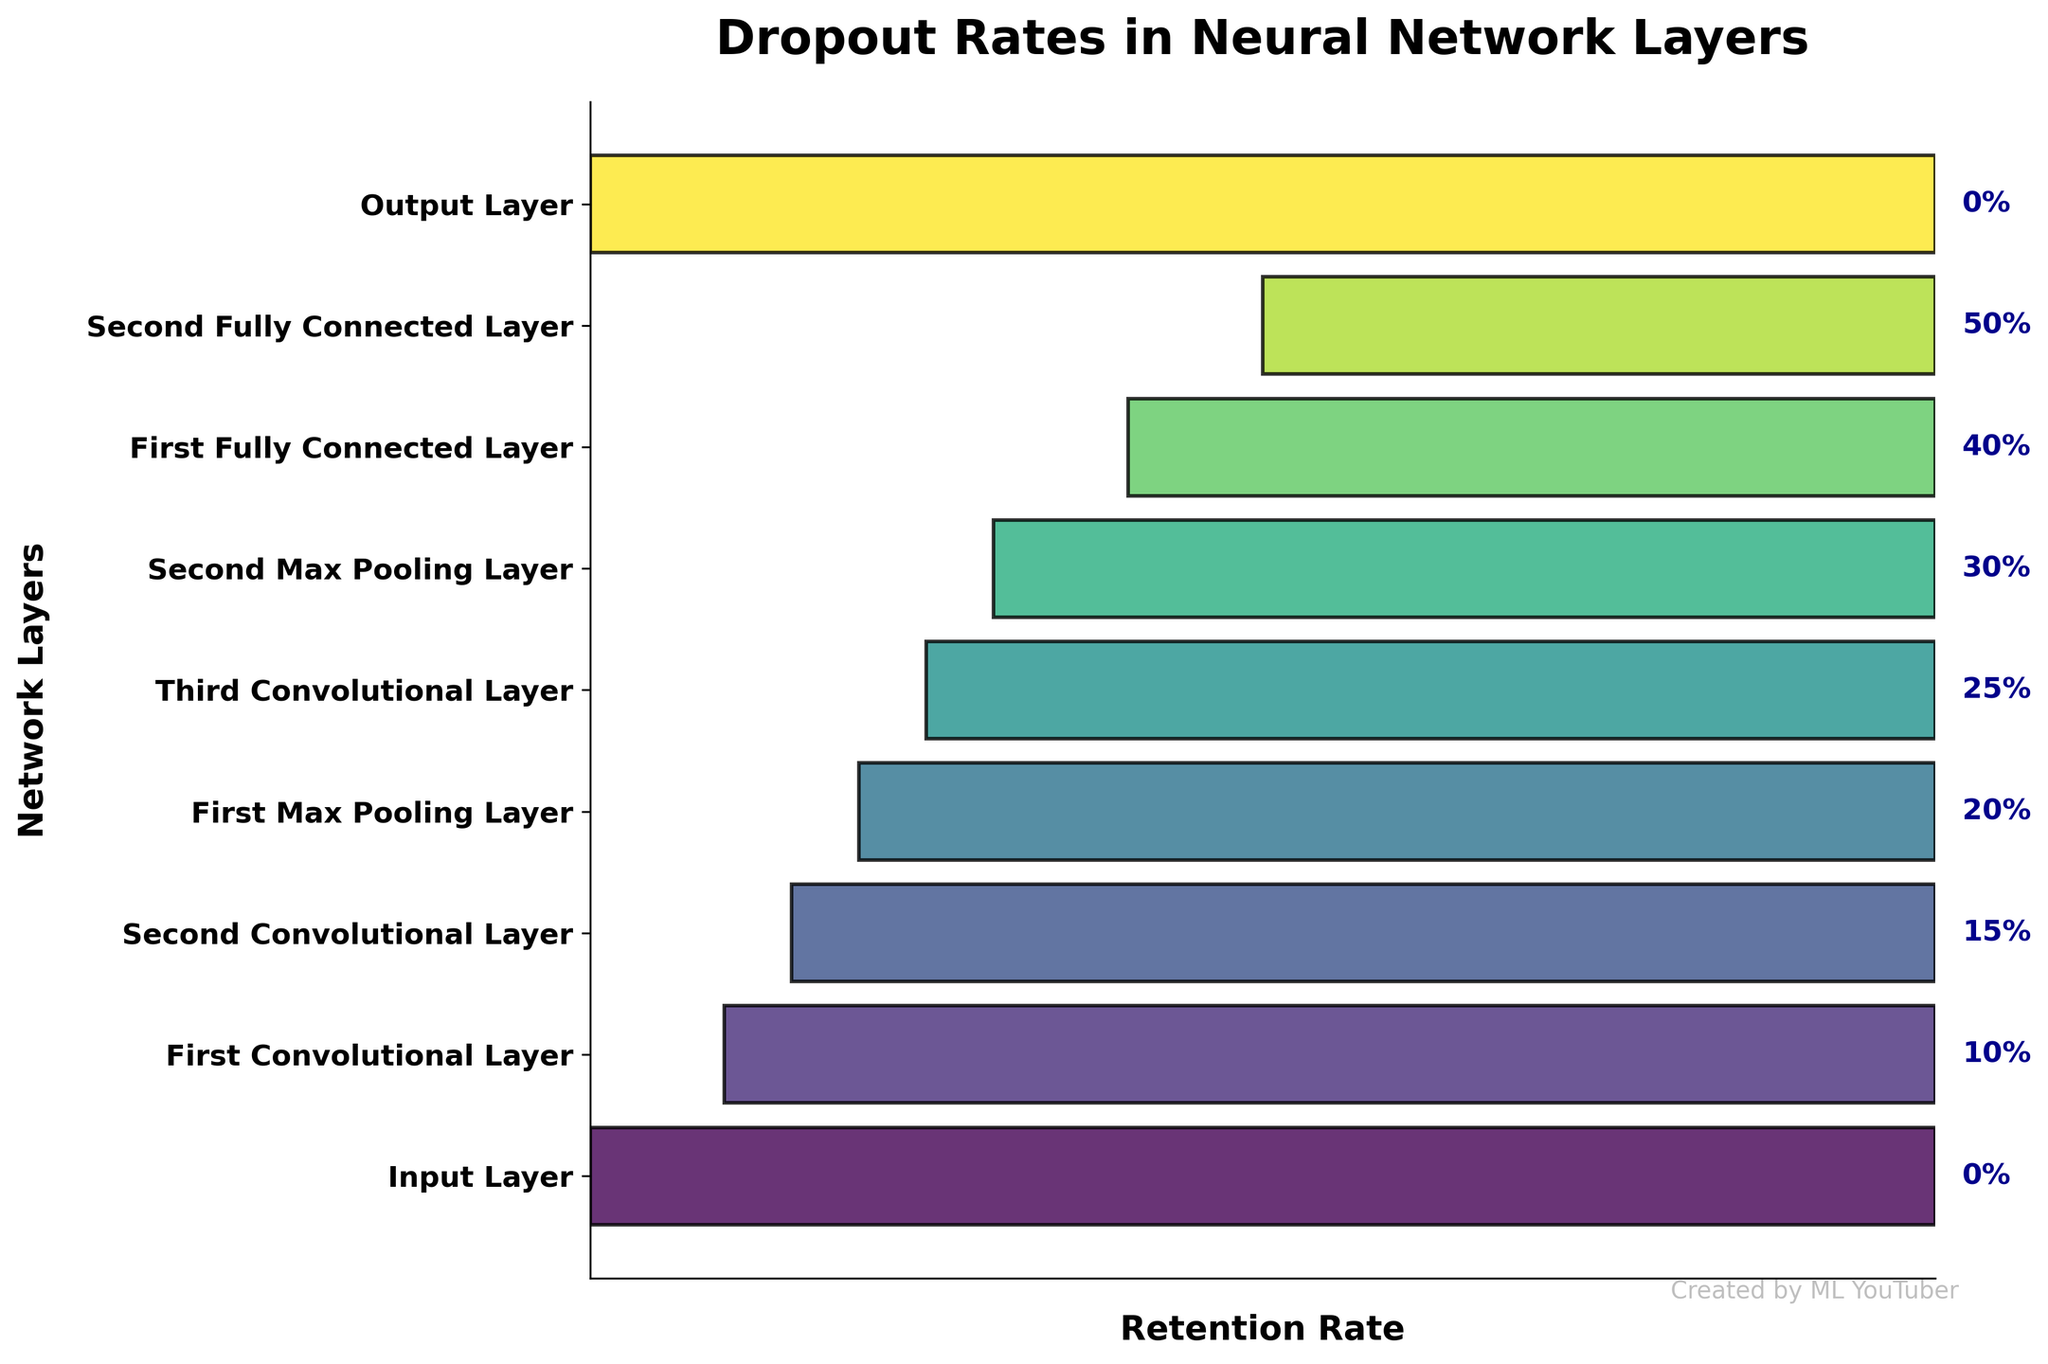How many layers have a dropout rate greater than 20%? Look at the color bars that extend beyond 20% on the percentage scale. The relevant stages are 'Third Convolutional Layer', 'Second Max Pooling Layer', 'First Fully Connected Layer', and 'Second Fully Connected Layer', making a total of 4.
Answer: 4 What is the dropout rate of the 'First Max Pooling Layer'? Find the 'First Max Pooling Layer' on the vertical axis and check the percentage label aligned with it. The dropout rate is shown as 20%.
Answer: 20% Which layer has the highest dropout rate? Identify the layer with the largest shaded segment. The 'Second Fully Connected Layer' has the highest dropout rate of 50%.
Answer: Second Fully Connected Layer What is the sum of the dropout rates for the 'Second Convolutional Layer' and 'First Fully Connected Layer'? Locate the 'Second Convolutional Layer' and 'First Fully Connected Layer' to find their dropout rates, which are 15% and 40%, respectively. Adding these rates gives 15% + 40% = 55%.
Answer: 55% Is the dropout rate of the 'Third Convolutional Layer' higher than that of the 'First Convolutional Layer'? Compare the rates of 'Third Convolutional Layer' and 'First Convolutional Layer'. The rates are 25% and 10%, respectively, making the dropout rate of the 'Third Convolutional Layer' higher.
Answer: Yes Which layers have a dropout rate of 0%? Look for the layers with no shaded portion. 'Input Layer' and 'Output Layer' both have a dropout rate of 0%.
Answer: Input Layer, Output Layer What is the average dropout rate of all layers excluding the 'Input Layer' and 'Output Layer'? Exclude the 'Input Layer' and 'Output Layer', and sum the dropout rates of the remaining layers (10% + 15% + 20% + 25% + 30% + 40% + 50% = 190%). Divide by the number of layers excluding 'Input Layer' and 'Output Layer' (7), so the average is 190% / 7 ≈ 27.14%.
Answer: 27.14% Between which two consecutive layers is the largest increase in dropout rate observed? Calculate the rate differences between consecutive layers: 
- First Conv vs. Input: 10% - 0% = 10% 
- Second Conv vs. First Conv: 15% - 10% = 5% 
- First Max Pool vs. Second Conv: 20% - 15% = 5% 
- Third Conv vs. First Max Pool: 25% - 20% = 5% 
- Second Max Pool vs. Third Conv: 30% - 25% = 5% 
- First FC vs. Second Max Pool: 40% - 30% = 10% 
- Second FC vs. First FC: 50% - 40% = 10% 
The largest increase of 10% occurs between both 'First Convolutional Layer' and 'Input Layer', and 'Second Fully Connected Layer' and 'First Convolutional Layer'.
Answer: Input Layer and First Convolutional Layer, First Fully Connected Layer and Second Fully Connected Layer What is the retention rate at the 'Second Max Pooling Layer'? The retention rate is simply 100% minus the dropout rate for the 'Second Max Pooling Layer'. With a dropout rate of 30%, the retention rate is 70%.
Answer: 70% 